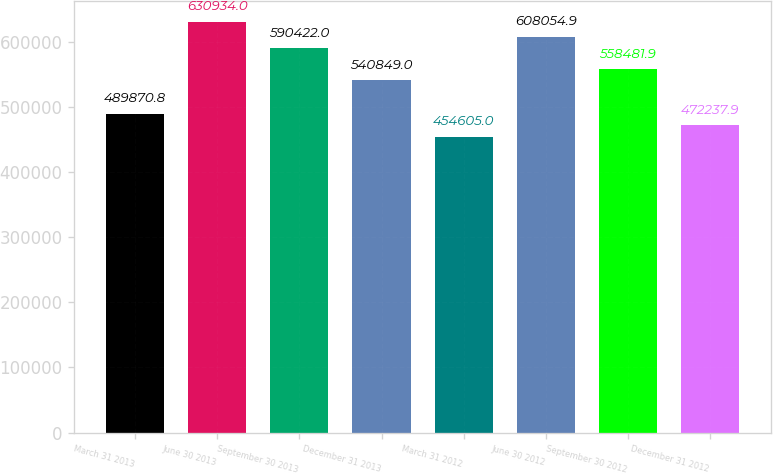Convert chart to OTSL. <chart><loc_0><loc_0><loc_500><loc_500><bar_chart><fcel>March 31 2013<fcel>June 30 2013<fcel>September 30 2013<fcel>December 31 2013<fcel>March 31 2012<fcel>June 30 2012<fcel>September 30 2012<fcel>December 31 2012<nl><fcel>489871<fcel>630934<fcel>590422<fcel>540849<fcel>454605<fcel>608055<fcel>558482<fcel>472238<nl></chart> 